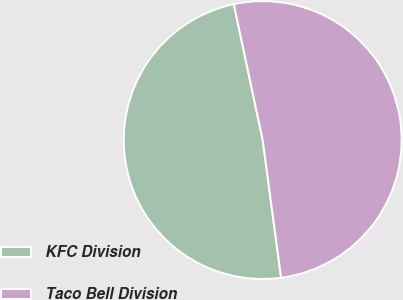Convert chart to OTSL. <chart><loc_0><loc_0><loc_500><loc_500><pie_chart><fcel>KFC Division<fcel>Taco Bell Division<nl><fcel>48.78%<fcel>51.22%<nl></chart> 